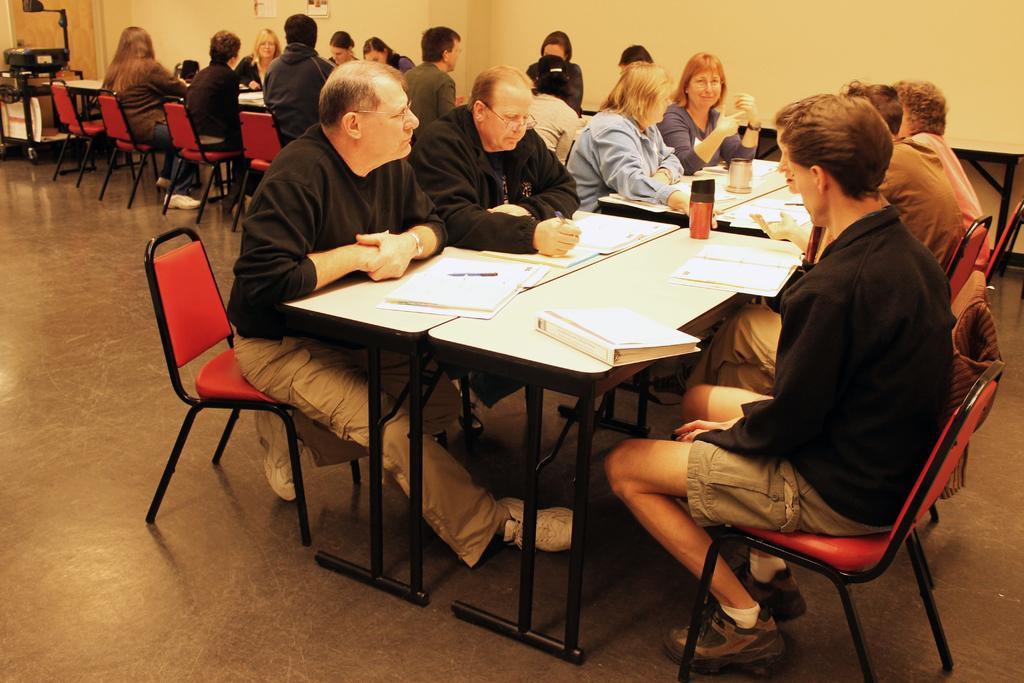In one or two sentences, can you explain what this image depicts? The image is taken in a closed room in which there are number of people sitting on the chairs in front of the tables and on the table there are books and some glasses and at the right corner of the picture one person is in the black dress wearing shoes and in the left corner of the picture there is one small cart behind it there is a door, behind the people there is a wall. 